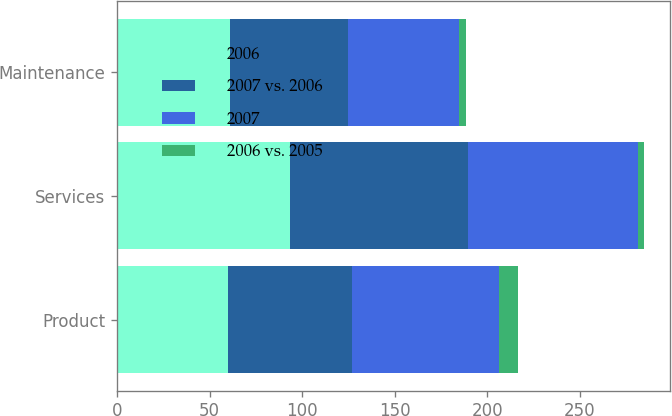Convert chart to OTSL. <chart><loc_0><loc_0><loc_500><loc_500><stacked_bar_chart><ecel><fcel>Product<fcel>Services<fcel>Maintenance<nl><fcel>2006<fcel>60.1<fcel>93.4<fcel>61.1<nl><fcel>2007 vs. 2006<fcel>66.8<fcel>96.5<fcel>63.8<nl><fcel>2007<fcel>79.7<fcel>91.9<fcel>59.8<nl><fcel>2006 vs. 2005<fcel>10<fcel>3<fcel>4<nl></chart> 